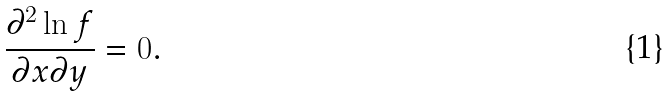Convert formula to latex. <formula><loc_0><loc_0><loc_500><loc_500>\frac { \partial ^ { 2 } \ln f } { \partial x \partial y } = 0 .</formula> 